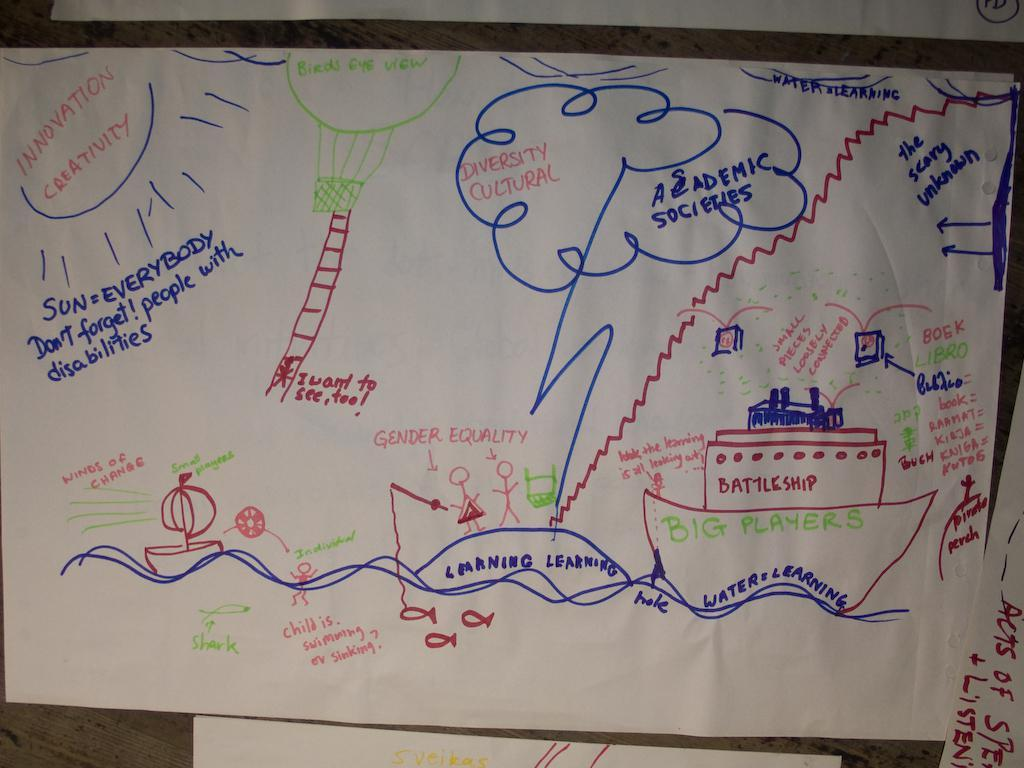Provide a one-sentence caption for the provided image. A piece of paper with outlining an Academic Series. 